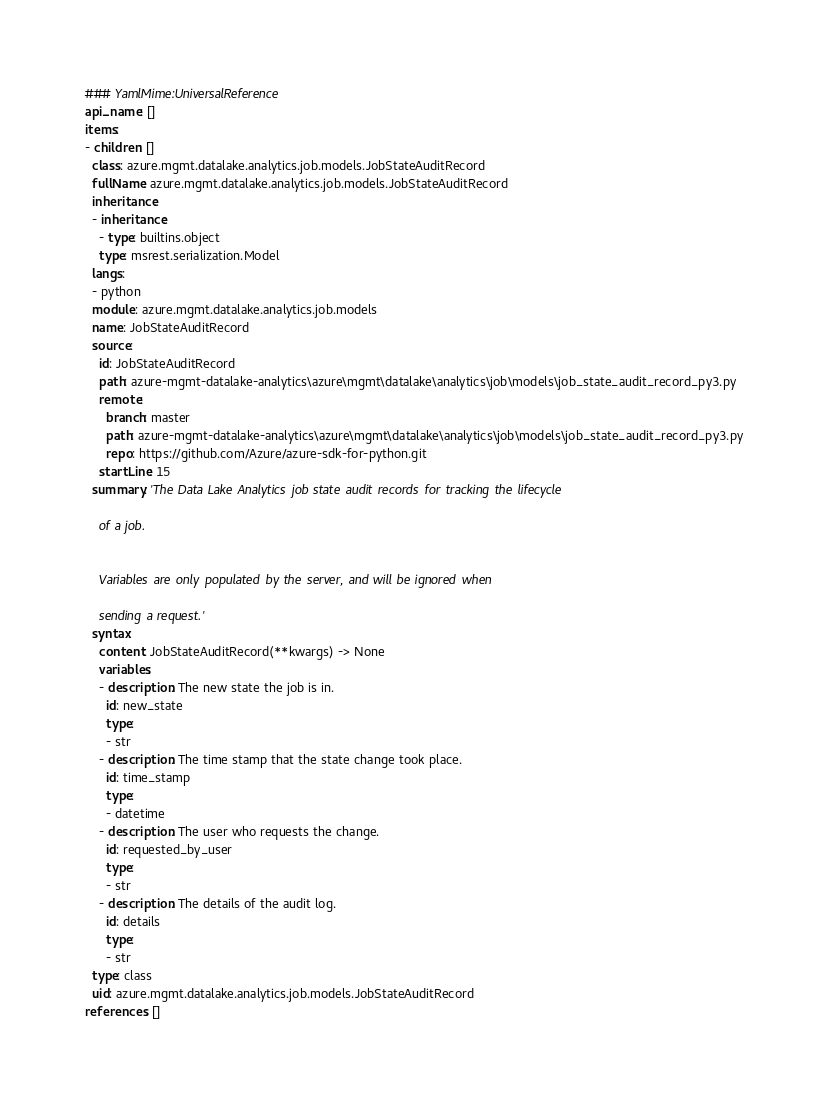Convert code to text. <code><loc_0><loc_0><loc_500><loc_500><_YAML_>### YamlMime:UniversalReference
api_name: []
items:
- children: []
  class: azure.mgmt.datalake.analytics.job.models.JobStateAuditRecord
  fullName: azure.mgmt.datalake.analytics.job.models.JobStateAuditRecord
  inheritance:
  - inheritance:
    - type: builtins.object
    type: msrest.serialization.Model
  langs:
  - python
  module: azure.mgmt.datalake.analytics.job.models
  name: JobStateAuditRecord
  source:
    id: JobStateAuditRecord
    path: azure-mgmt-datalake-analytics\azure\mgmt\datalake\analytics\job\models\job_state_audit_record_py3.py
    remote:
      branch: master
      path: azure-mgmt-datalake-analytics\azure\mgmt\datalake\analytics\job\models\job_state_audit_record_py3.py
      repo: https://github.com/Azure/azure-sdk-for-python.git
    startLine: 15
  summary: 'The Data Lake Analytics job state audit records for tracking the lifecycle

    of a job.


    Variables are only populated by the server, and will be ignored when

    sending a request.'
  syntax:
    content: JobStateAuditRecord(**kwargs) -> None
    variables:
    - description: The new state the job is in.
      id: new_state
      type:
      - str
    - description: The time stamp that the state change took place.
      id: time_stamp
      type:
      - datetime
    - description: The user who requests the change.
      id: requested_by_user
      type:
      - str
    - description: The details of the audit log.
      id: details
      type:
      - str
  type: class
  uid: azure.mgmt.datalake.analytics.job.models.JobStateAuditRecord
references: []
</code> 